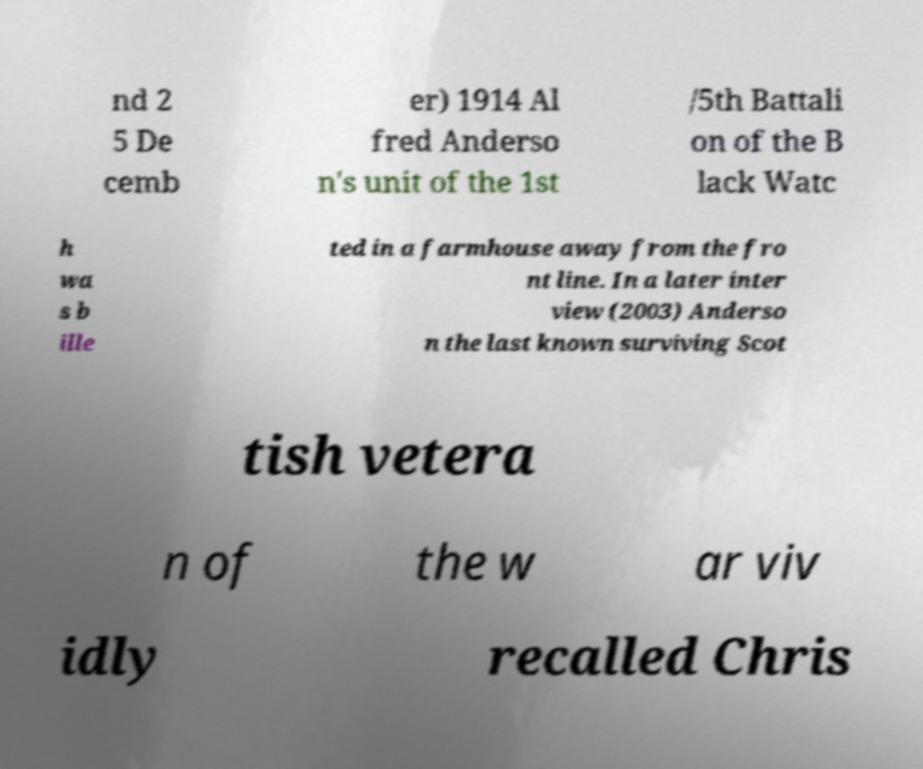Can you accurately transcribe the text from the provided image for me? nd 2 5 De cemb er) 1914 Al fred Anderso n's unit of the 1st /5th Battali on of the B lack Watc h wa s b ille ted in a farmhouse away from the fro nt line. In a later inter view (2003) Anderso n the last known surviving Scot tish vetera n of the w ar viv idly recalled Chris 